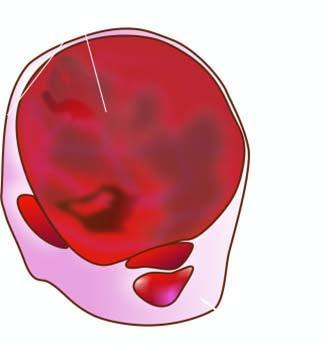s the thyroid gland enlarged diffusely?
Answer the question using a single word or phrase. Yes 